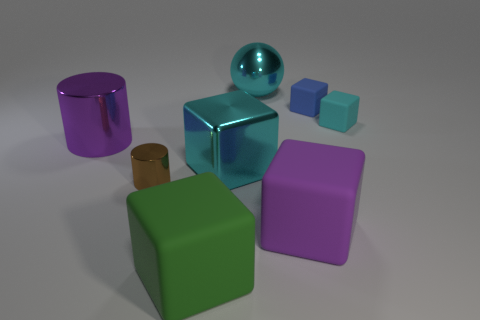How would you describe the arrangement of these objects? The objects are arranged with a sense of balance and spacing that gives each item its own prominence. The larger shapes are toward the back, and the smaller items are in front, creating a sense of depth. The arrangement is somewhat clustered but doesn't appear random, suggesting a deliberate attempt to display the objects together in a visually pleasing manner. 